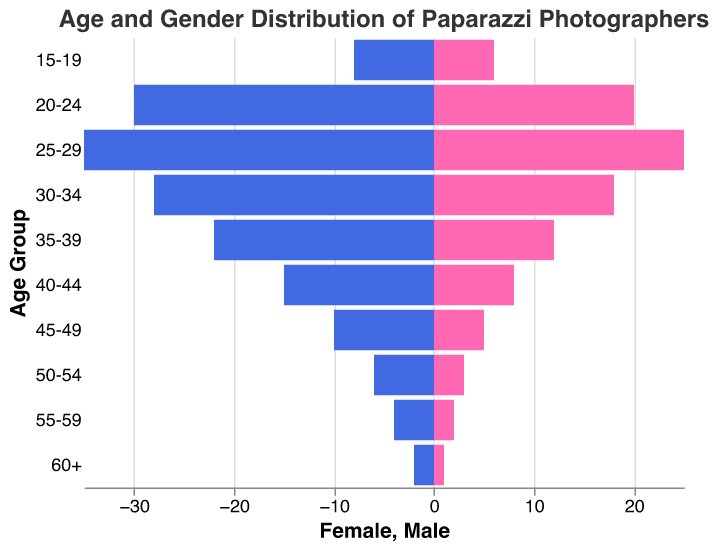Which age group has the highest number of male paparazzi photographers? Look at the longest blue bar representing the male population. The 25-29 age group has the longest blue bar, indicating the highest number of male photographers.
Answer: 25-29 Which age group has the fewest female paparazzi photographers? Look at the shortest pink bar representing the female population. The 60+ age group has the shortest pink bar, indicating the fewest number of female photographers.
Answer: 60+ What is the total number of paparazzi photographers in the 30-34 age group? Add the number of male and female photographers in the 30-34 age group (Male: 28, Female: 18). 28 + 18 = 46
Answer: 46 How many more male than female paparazzi photographers are there in the 40-44 age group? Subtract the number of female photographers from the number of male photographers in the 40-44 age group (Male: 15, Female: 8). 15 - 8 = 7
Answer: 7 Which two age groups have the same number of female paparazzi photographers? Identify age groups where the pink bars are of equal length. Both the 55-59 and 50-54 age groups have 2 and 3 female photographers respectively.
Answer: 55-59 and 50-54 What is the total number of female paparazzi photographers across all age groups? Sum the female counts for all age groups (1+2+3+5+8+12+18+25+20+6). The total is 100.
Answer: 100 Are there more male or female paparazzi photographers in the 20-24 age group? Compare the length of the blue and pink bars in the 20-24 age group. The blue bar (Male: 30) is longer than the pink bar (Female: 20).
Answer: Male What is the average number of male paparazzi photographers in the age ranges from 25-29 to 35-39? Add the male counts for the age groups 25-29 (35), 30-34 (28), and 35-39 (22) and then divide by the number of age groups. (35+28+22)/3 = 28.33
Answer: 28.33 Which age group has a greater gender disparity, 35-39 or 45-49? Calculate the difference between males and females in both age groups: 35-39 (22-12=10), and 45-49 (10-5=5). Age group 35-39 has a greater disparity of 10.
Answer: 35-39 